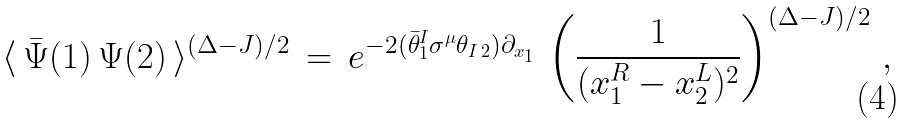Convert formula to latex. <formula><loc_0><loc_0><loc_500><loc_500>\langle \, \bar { \Psi } ( 1 ) \, \Psi ( 2 ) \, \rangle ^ { ( \Delta - J ) / 2 } \, = \, e ^ { - 2 ( \bar { \theta } ^ { I } _ { 1 } \sigma ^ { \mu } \theta _ { I \, 2 } ) \partial _ { x _ { 1 } } } \, \left ( \frac { 1 } { ( x ^ { R } _ { 1 } - x ^ { L } _ { 2 } ) ^ { 2 } } \right ) ^ { ( \Delta - J ) / 2 } \, ,</formula> 